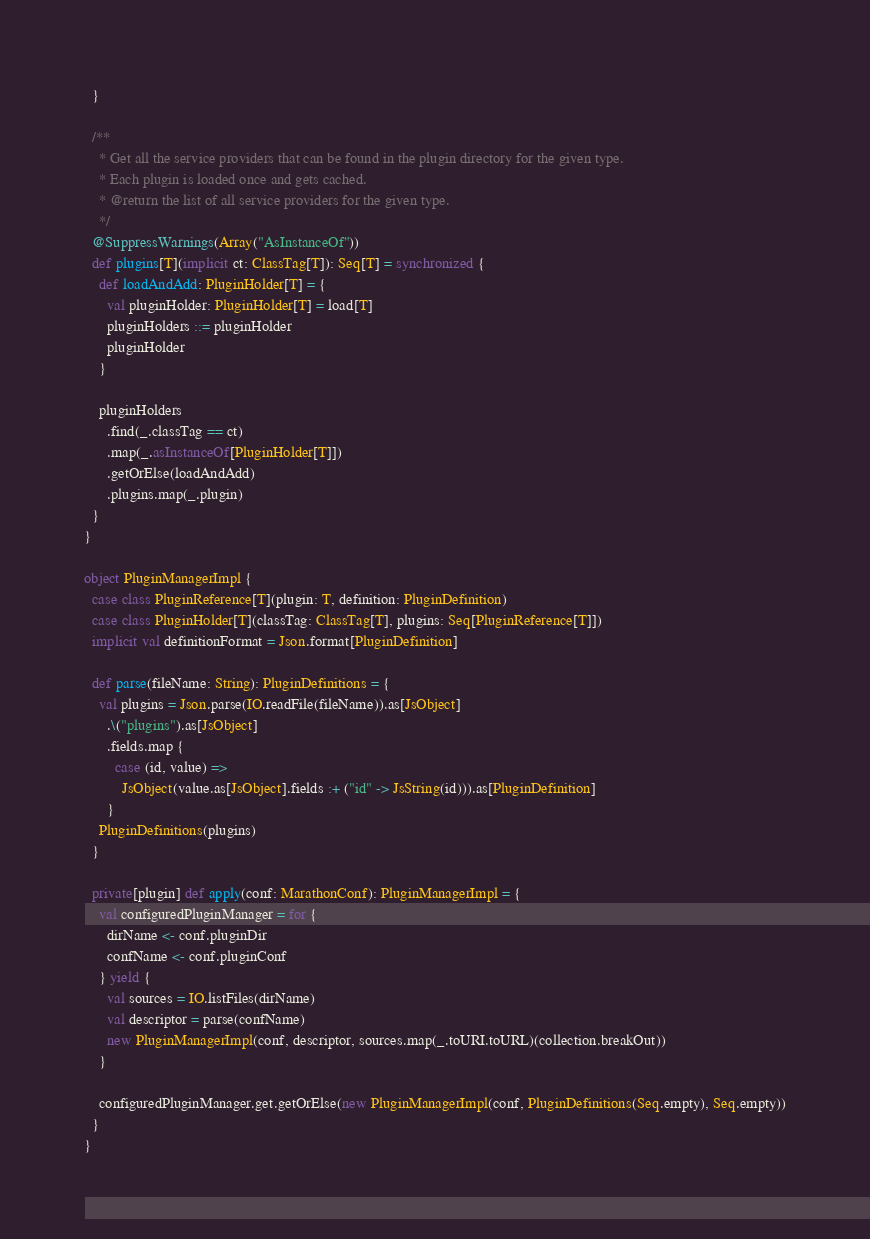<code> <loc_0><loc_0><loc_500><loc_500><_Scala_>  }

  /**
    * Get all the service providers that can be found in the plugin directory for the given type.
    * Each plugin is loaded once and gets cached.
    * @return the list of all service providers for the given type.
    */
  @SuppressWarnings(Array("AsInstanceOf"))
  def plugins[T](implicit ct: ClassTag[T]): Seq[T] = synchronized {
    def loadAndAdd: PluginHolder[T] = {
      val pluginHolder: PluginHolder[T] = load[T]
      pluginHolders ::= pluginHolder
      pluginHolder
    }

    pluginHolders
      .find(_.classTag == ct)
      .map(_.asInstanceOf[PluginHolder[T]])
      .getOrElse(loadAndAdd)
      .plugins.map(_.plugin)
  }
}

object PluginManagerImpl {
  case class PluginReference[T](plugin: T, definition: PluginDefinition)
  case class PluginHolder[T](classTag: ClassTag[T], plugins: Seq[PluginReference[T]])
  implicit val definitionFormat = Json.format[PluginDefinition]

  def parse(fileName: String): PluginDefinitions = {
    val plugins = Json.parse(IO.readFile(fileName)).as[JsObject]
      .\("plugins").as[JsObject]
      .fields.map {
        case (id, value) =>
          JsObject(value.as[JsObject].fields :+ ("id" -> JsString(id))).as[PluginDefinition]
      }
    PluginDefinitions(plugins)
  }

  private[plugin] def apply(conf: MarathonConf): PluginManagerImpl = {
    val configuredPluginManager = for {
      dirName <- conf.pluginDir
      confName <- conf.pluginConf
    } yield {
      val sources = IO.listFiles(dirName)
      val descriptor = parse(confName)
      new PluginManagerImpl(conf, descriptor, sources.map(_.toURI.toURL)(collection.breakOut))
    }

    configuredPluginManager.get.getOrElse(new PluginManagerImpl(conf, PluginDefinitions(Seq.empty), Seq.empty))
  }
}

</code> 